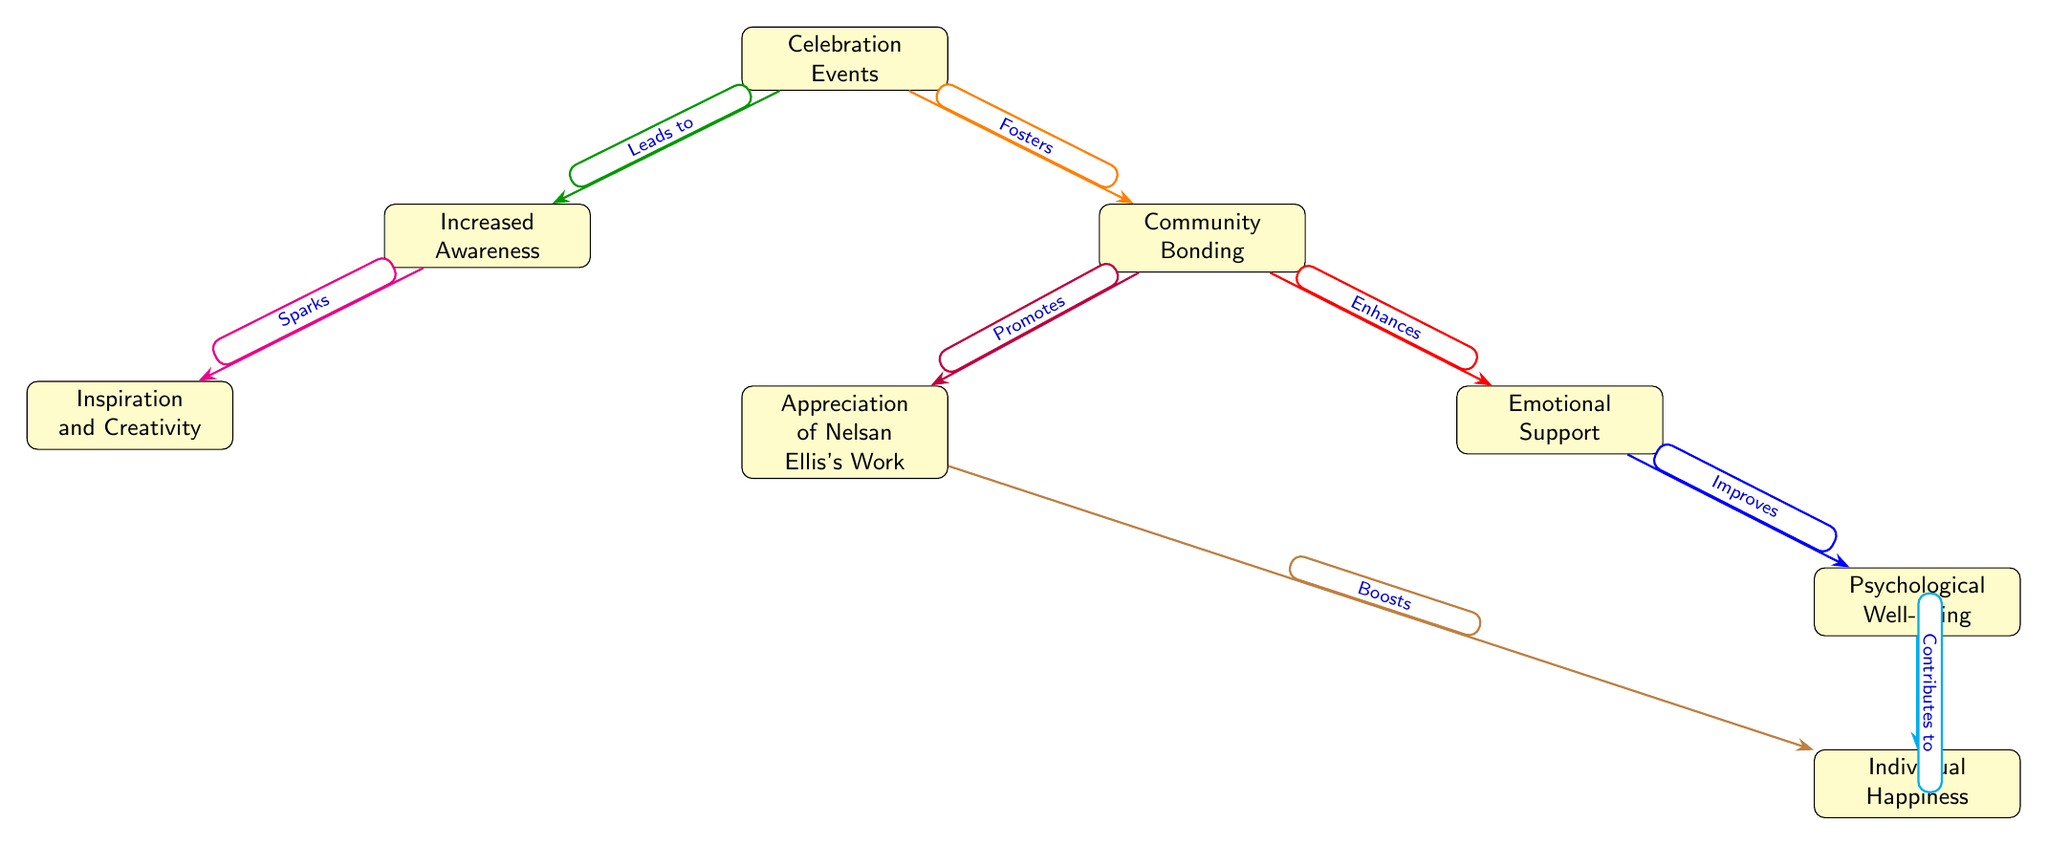What is the central node of the diagram? The central node is "Celebration Events," which connects to multiple other nodes.
Answer: Celebration Events How many edges are coming out of the "Community Bonding" node? The "Community Bonding" node has two edges coming out of it, leading to "Emotional Support" and "Appreciation of Nelsan Ellis's Work."
Answer: 2 What effect does "Celebration Events" have on "Increased Awareness"? The diagram indicates that "Celebration Events" leads to "Increased Awareness."
Answer: Leads to What improves "Psychological Well-being"? "Emotional Support" improves "Psychological Well-being," as indicated by one of the arrows in the diagram.
Answer: Improves Which node is enhanced by "Community Bonding"? "Emotional Support" is enhanced by "Community Bonding," as indicated by the relationship shown in the diagram.
Answer: Enhances How does "Appreciation of Nelsan Ellis's Work" affect "Individual Happiness"? "Appreciation of Nelsan Ellis's Work" boosts "Individual Happiness," according to the diagram.
Answer: Boosts What sparks "Inspiration and Creativity"? The node "Increased Awareness" sparks "Inspiration and Creativity" as shown by the arrow connecting them.
Answer: Sparks What contributes to "Individual Happiness"? "Psychological Well-being" contributes to "Individual Happiness," according to the flow of the diagram.
Answer: Contributes to What is connected directly to the "Celebration Events" node? The nodes directly connected to "Celebration Events" are "Community Bonding" and "Increased Awareness."
Answer: Community Bonding, Increased Awareness 